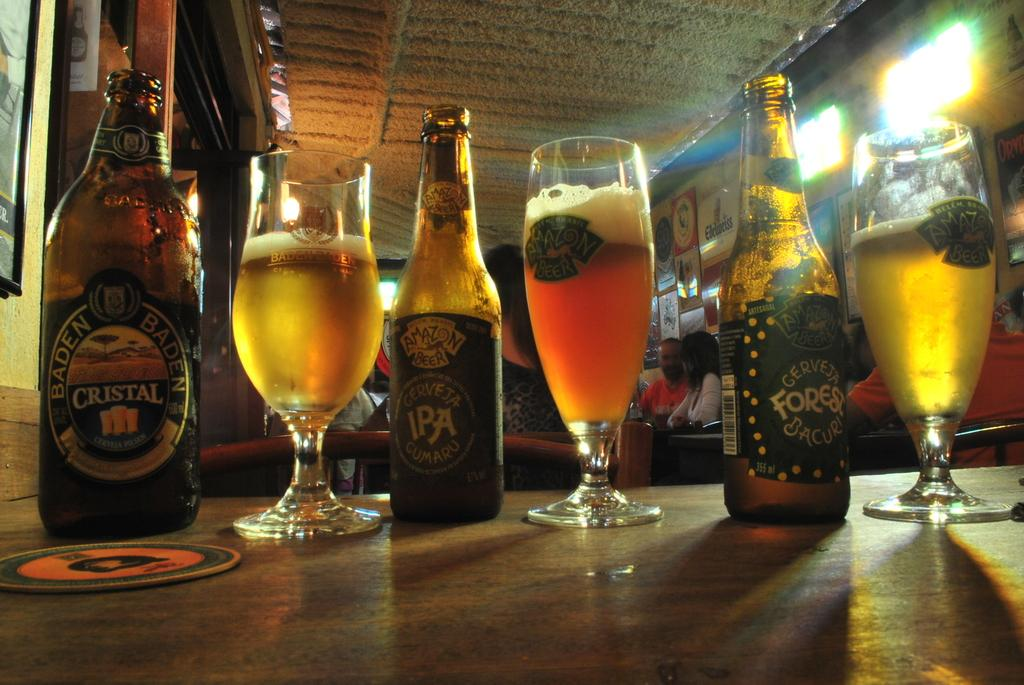Provide a one-sentence caption for the provided image. bottles and glasses of beer like Cristal and IPA. 